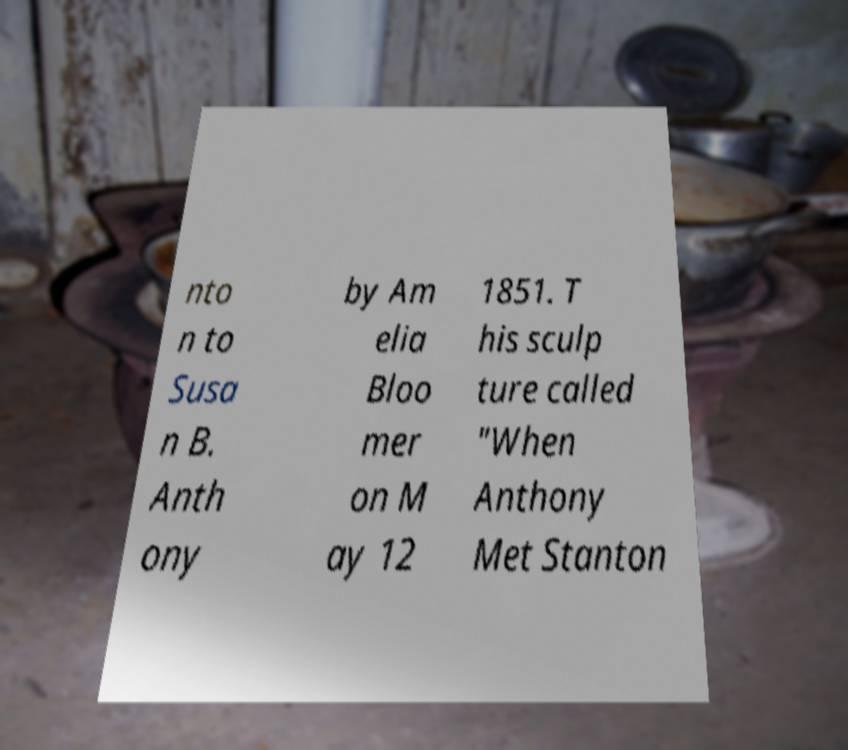I need the written content from this picture converted into text. Can you do that? nto n to Susa n B. Anth ony by Am elia Bloo mer on M ay 12 1851. T his sculp ture called "When Anthony Met Stanton 